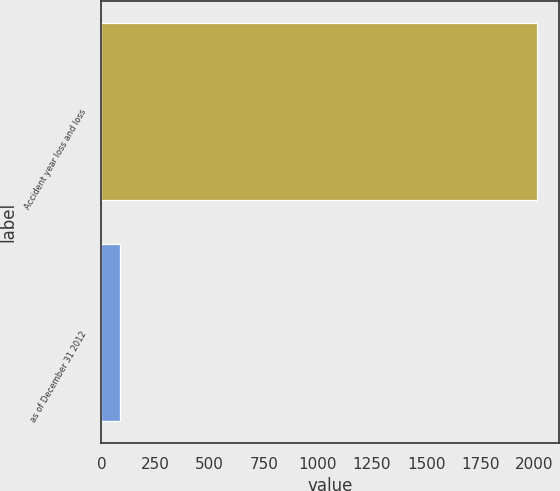Convert chart to OTSL. <chart><loc_0><loc_0><loc_500><loc_500><bar_chart><fcel>Accident year loss and loss<fcel>as of December 31 2012<nl><fcel>2012<fcel>85.4<nl></chart> 